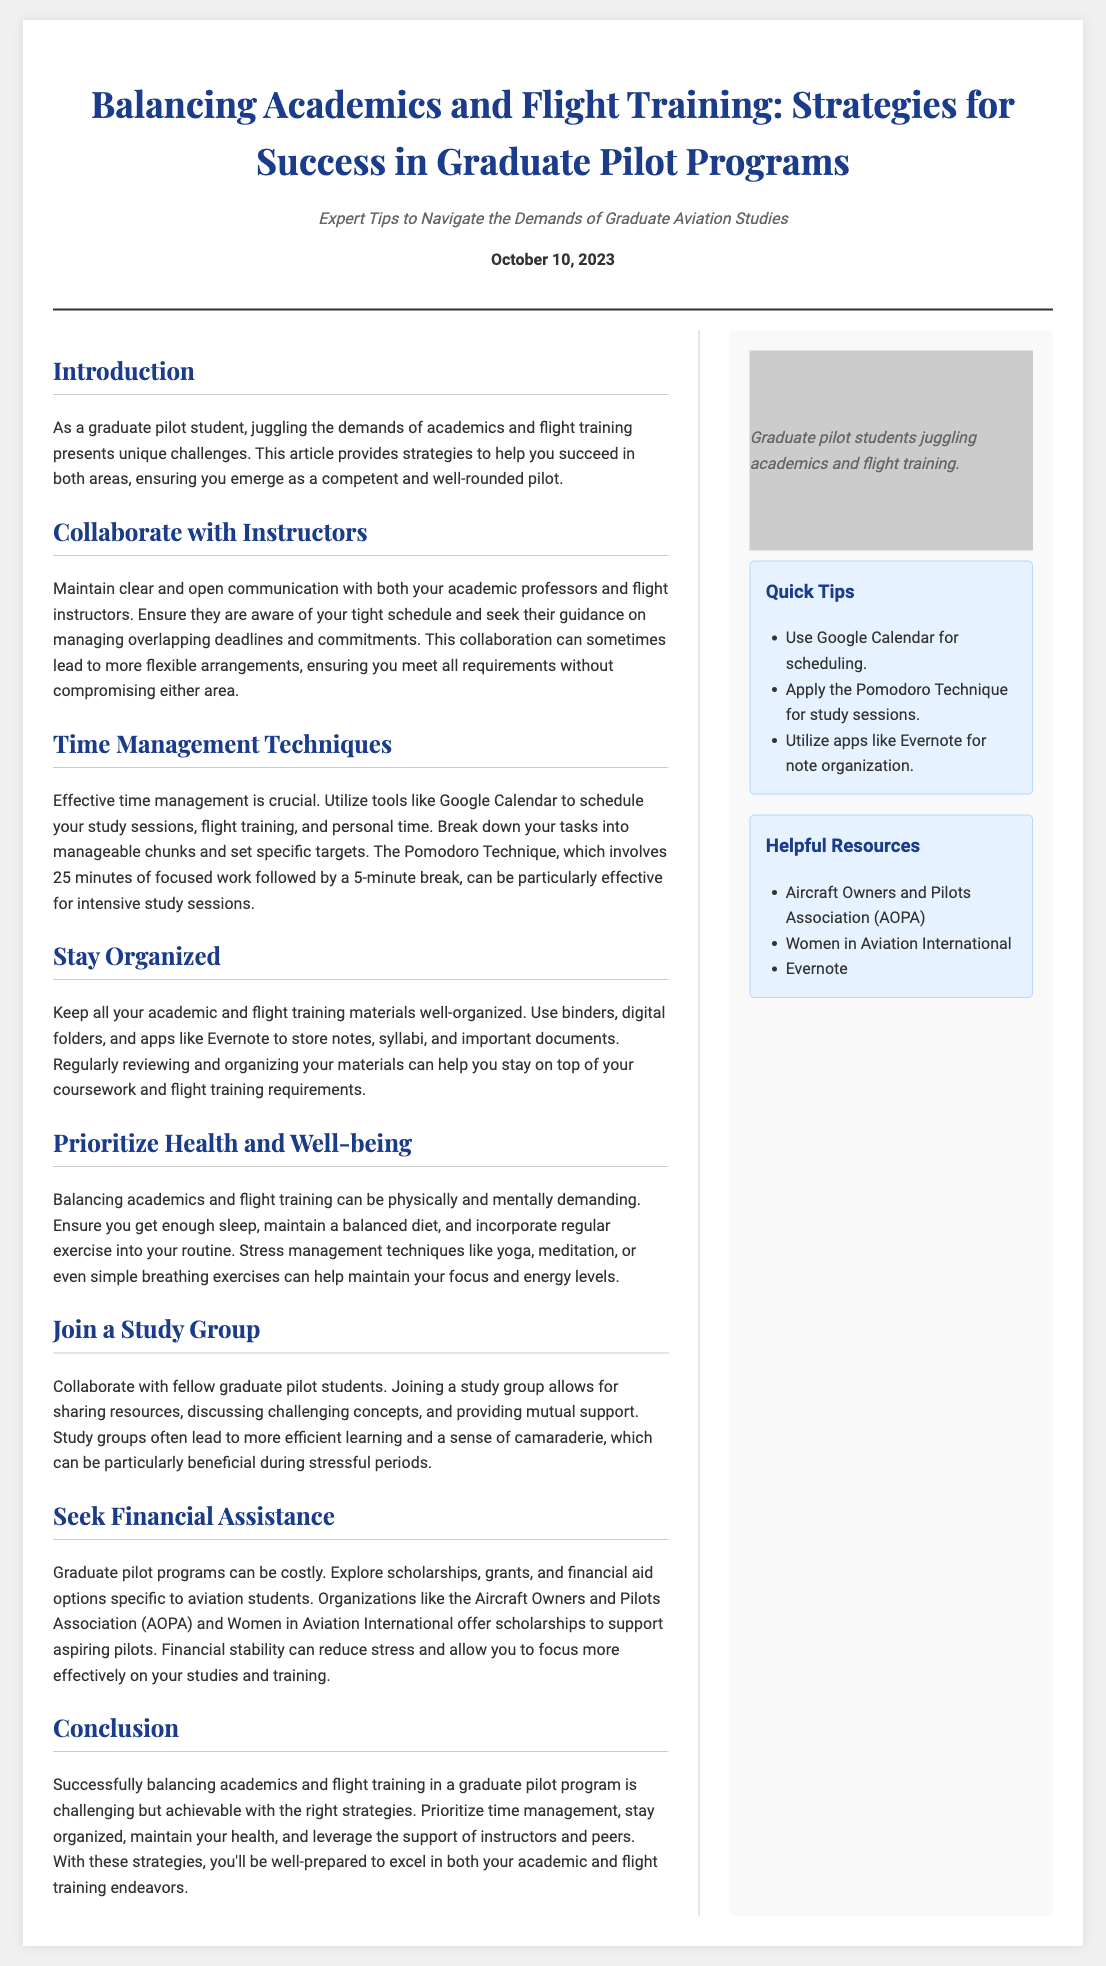what is the title of the article? The title of the article is presented prominently at the top of the document.
Answer: Balancing Academics and Flight Training: Strategies for Success in Graduate Pilot Programs when was the article published? The publication date is mentioned in the header section of the document.
Answer: October 10, 2023 what is one time management technique suggested in the article? The article mentions specific techniques for managing time effectively.
Answer: Pomodoro Technique what organization offers scholarships for aspiring pilots? The article lists organizations that support aviation students, including scholarships.
Answer: Aircraft Owners and Pilots Association (AOPA) what is one benefit of joining a study group? The article outlines advantages of group collaboration among students.
Answer: Mutual support what health aspect should be prioritized according to the article? The article emphasizes the importance of maintaining health while balancing studies and training.
Answer: Well-being how many sections are in the main article? The number of sections can be counted from the headings within the main content.
Answer: Seven 